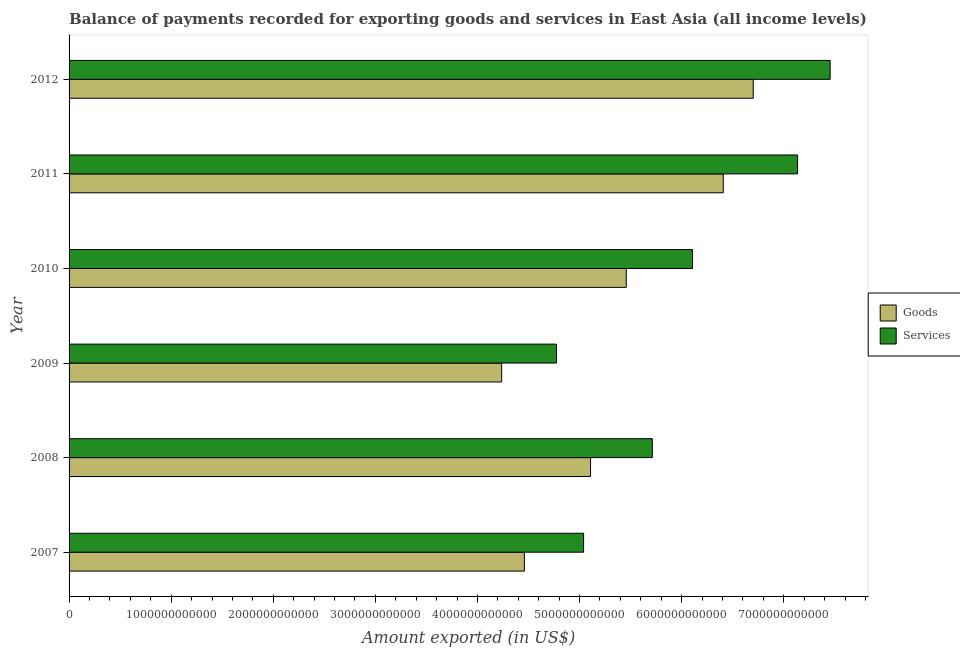Are the number of bars per tick equal to the number of legend labels?
Provide a succinct answer. Yes. How many bars are there on the 1st tick from the top?
Make the answer very short. 2. What is the label of the 2nd group of bars from the top?
Your response must be concise. 2011. In how many cases, is the number of bars for a given year not equal to the number of legend labels?
Your answer should be compact. 0. What is the amount of goods exported in 2007?
Keep it short and to the point. 4.46e+12. Across all years, what is the maximum amount of services exported?
Keep it short and to the point. 7.45e+12. Across all years, what is the minimum amount of goods exported?
Provide a succinct answer. 4.24e+12. In which year was the amount of services exported maximum?
Offer a terse response. 2012. In which year was the amount of goods exported minimum?
Keep it short and to the point. 2009. What is the total amount of services exported in the graph?
Give a very brief answer. 3.62e+13. What is the difference between the amount of services exported in 2007 and that in 2009?
Make the answer very short. 2.66e+11. What is the difference between the amount of services exported in 2008 and the amount of goods exported in 2012?
Ensure brevity in your answer.  -9.88e+11. What is the average amount of services exported per year?
Give a very brief answer. 6.04e+12. In the year 2009, what is the difference between the amount of goods exported and amount of services exported?
Offer a terse response. -5.37e+11. Is the amount of goods exported in 2007 less than that in 2011?
Offer a very short reply. Yes. Is the difference between the amount of services exported in 2008 and 2010 greater than the difference between the amount of goods exported in 2008 and 2010?
Your response must be concise. No. What is the difference between the highest and the second highest amount of services exported?
Offer a terse response. 3.19e+11. What is the difference between the highest and the lowest amount of services exported?
Provide a short and direct response. 2.68e+12. In how many years, is the amount of goods exported greater than the average amount of goods exported taken over all years?
Give a very brief answer. 3. What does the 1st bar from the top in 2012 represents?
Offer a very short reply. Services. What does the 1st bar from the bottom in 2011 represents?
Offer a terse response. Goods. How many years are there in the graph?
Your answer should be very brief. 6. What is the difference between two consecutive major ticks on the X-axis?
Your response must be concise. 1.00e+12. Are the values on the major ticks of X-axis written in scientific E-notation?
Your response must be concise. No. Does the graph contain any zero values?
Offer a very short reply. No. Where does the legend appear in the graph?
Give a very brief answer. Center right. How many legend labels are there?
Your answer should be very brief. 2. What is the title of the graph?
Offer a terse response. Balance of payments recorded for exporting goods and services in East Asia (all income levels). What is the label or title of the X-axis?
Your answer should be very brief. Amount exported (in US$). What is the Amount exported (in US$) of Goods in 2007?
Keep it short and to the point. 4.46e+12. What is the Amount exported (in US$) of Services in 2007?
Make the answer very short. 5.04e+12. What is the Amount exported (in US$) of Goods in 2008?
Your response must be concise. 5.11e+12. What is the Amount exported (in US$) in Services in 2008?
Provide a succinct answer. 5.71e+12. What is the Amount exported (in US$) of Goods in 2009?
Your response must be concise. 4.24e+12. What is the Amount exported (in US$) of Services in 2009?
Offer a terse response. 4.77e+12. What is the Amount exported (in US$) of Goods in 2010?
Keep it short and to the point. 5.46e+12. What is the Amount exported (in US$) in Services in 2010?
Keep it short and to the point. 6.11e+12. What is the Amount exported (in US$) in Goods in 2011?
Your answer should be compact. 6.41e+12. What is the Amount exported (in US$) in Services in 2011?
Give a very brief answer. 7.14e+12. What is the Amount exported (in US$) of Goods in 2012?
Your answer should be compact. 6.70e+12. What is the Amount exported (in US$) in Services in 2012?
Offer a very short reply. 7.45e+12. Across all years, what is the maximum Amount exported (in US$) of Goods?
Make the answer very short. 6.70e+12. Across all years, what is the maximum Amount exported (in US$) of Services?
Your answer should be compact. 7.45e+12. Across all years, what is the minimum Amount exported (in US$) in Goods?
Provide a succinct answer. 4.24e+12. Across all years, what is the minimum Amount exported (in US$) in Services?
Your answer should be very brief. 4.77e+12. What is the total Amount exported (in US$) of Goods in the graph?
Offer a very short reply. 3.24e+13. What is the total Amount exported (in US$) of Services in the graph?
Give a very brief answer. 3.62e+13. What is the difference between the Amount exported (in US$) in Goods in 2007 and that in 2008?
Your answer should be very brief. -6.48e+11. What is the difference between the Amount exported (in US$) of Services in 2007 and that in 2008?
Offer a very short reply. -6.73e+11. What is the difference between the Amount exported (in US$) in Goods in 2007 and that in 2009?
Your answer should be compact. 2.22e+11. What is the difference between the Amount exported (in US$) of Services in 2007 and that in 2009?
Offer a terse response. 2.66e+11. What is the difference between the Amount exported (in US$) of Goods in 2007 and that in 2010?
Provide a succinct answer. -9.98e+11. What is the difference between the Amount exported (in US$) of Services in 2007 and that in 2010?
Provide a short and direct response. -1.07e+12. What is the difference between the Amount exported (in US$) of Goods in 2007 and that in 2011?
Offer a very short reply. -1.95e+12. What is the difference between the Amount exported (in US$) in Services in 2007 and that in 2011?
Keep it short and to the point. -2.10e+12. What is the difference between the Amount exported (in US$) of Goods in 2007 and that in 2012?
Keep it short and to the point. -2.24e+12. What is the difference between the Amount exported (in US$) of Services in 2007 and that in 2012?
Keep it short and to the point. -2.41e+12. What is the difference between the Amount exported (in US$) in Goods in 2008 and that in 2009?
Your response must be concise. 8.71e+11. What is the difference between the Amount exported (in US$) of Services in 2008 and that in 2009?
Your response must be concise. 9.39e+11. What is the difference between the Amount exported (in US$) in Goods in 2008 and that in 2010?
Offer a terse response. -3.50e+11. What is the difference between the Amount exported (in US$) of Services in 2008 and that in 2010?
Keep it short and to the point. -3.94e+11. What is the difference between the Amount exported (in US$) in Goods in 2008 and that in 2011?
Your response must be concise. -1.30e+12. What is the difference between the Amount exported (in US$) in Services in 2008 and that in 2011?
Provide a succinct answer. -1.42e+12. What is the difference between the Amount exported (in US$) in Goods in 2008 and that in 2012?
Offer a very short reply. -1.59e+12. What is the difference between the Amount exported (in US$) of Services in 2008 and that in 2012?
Your answer should be very brief. -1.74e+12. What is the difference between the Amount exported (in US$) in Goods in 2009 and that in 2010?
Provide a succinct answer. -1.22e+12. What is the difference between the Amount exported (in US$) in Services in 2009 and that in 2010?
Make the answer very short. -1.33e+12. What is the difference between the Amount exported (in US$) of Goods in 2009 and that in 2011?
Your answer should be very brief. -2.17e+12. What is the difference between the Amount exported (in US$) of Services in 2009 and that in 2011?
Keep it short and to the point. -2.36e+12. What is the difference between the Amount exported (in US$) of Goods in 2009 and that in 2012?
Provide a succinct answer. -2.46e+12. What is the difference between the Amount exported (in US$) of Services in 2009 and that in 2012?
Provide a succinct answer. -2.68e+12. What is the difference between the Amount exported (in US$) of Goods in 2010 and that in 2011?
Keep it short and to the point. -9.50e+11. What is the difference between the Amount exported (in US$) in Services in 2010 and that in 2011?
Give a very brief answer. -1.03e+12. What is the difference between the Amount exported (in US$) in Goods in 2010 and that in 2012?
Offer a terse response. -1.24e+12. What is the difference between the Amount exported (in US$) of Services in 2010 and that in 2012?
Keep it short and to the point. -1.35e+12. What is the difference between the Amount exported (in US$) of Goods in 2011 and that in 2012?
Offer a terse response. -2.93e+11. What is the difference between the Amount exported (in US$) of Services in 2011 and that in 2012?
Provide a succinct answer. -3.19e+11. What is the difference between the Amount exported (in US$) in Goods in 2007 and the Amount exported (in US$) in Services in 2008?
Your answer should be compact. -1.25e+12. What is the difference between the Amount exported (in US$) in Goods in 2007 and the Amount exported (in US$) in Services in 2009?
Your answer should be very brief. -3.14e+11. What is the difference between the Amount exported (in US$) in Goods in 2007 and the Amount exported (in US$) in Services in 2010?
Provide a succinct answer. -1.65e+12. What is the difference between the Amount exported (in US$) of Goods in 2007 and the Amount exported (in US$) of Services in 2011?
Provide a succinct answer. -2.68e+12. What is the difference between the Amount exported (in US$) of Goods in 2007 and the Amount exported (in US$) of Services in 2012?
Your answer should be compact. -2.99e+12. What is the difference between the Amount exported (in US$) in Goods in 2008 and the Amount exported (in US$) in Services in 2009?
Your answer should be very brief. 3.34e+11. What is the difference between the Amount exported (in US$) of Goods in 2008 and the Amount exported (in US$) of Services in 2010?
Your response must be concise. -9.99e+11. What is the difference between the Amount exported (in US$) of Goods in 2008 and the Amount exported (in US$) of Services in 2011?
Make the answer very short. -2.03e+12. What is the difference between the Amount exported (in US$) in Goods in 2008 and the Amount exported (in US$) in Services in 2012?
Provide a succinct answer. -2.35e+12. What is the difference between the Amount exported (in US$) of Goods in 2009 and the Amount exported (in US$) of Services in 2010?
Your response must be concise. -1.87e+12. What is the difference between the Amount exported (in US$) in Goods in 2009 and the Amount exported (in US$) in Services in 2011?
Your answer should be very brief. -2.90e+12. What is the difference between the Amount exported (in US$) in Goods in 2009 and the Amount exported (in US$) in Services in 2012?
Ensure brevity in your answer.  -3.22e+12. What is the difference between the Amount exported (in US$) of Goods in 2010 and the Amount exported (in US$) of Services in 2011?
Your answer should be very brief. -1.68e+12. What is the difference between the Amount exported (in US$) in Goods in 2010 and the Amount exported (in US$) in Services in 2012?
Your response must be concise. -2.00e+12. What is the difference between the Amount exported (in US$) of Goods in 2011 and the Amount exported (in US$) of Services in 2012?
Give a very brief answer. -1.05e+12. What is the average Amount exported (in US$) of Goods per year?
Offer a very short reply. 5.40e+12. What is the average Amount exported (in US$) in Services per year?
Make the answer very short. 6.04e+12. In the year 2007, what is the difference between the Amount exported (in US$) in Goods and Amount exported (in US$) in Services?
Your response must be concise. -5.80e+11. In the year 2008, what is the difference between the Amount exported (in US$) in Goods and Amount exported (in US$) in Services?
Ensure brevity in your answer.  -6.05e+11. In the year 2009, what is the difference between the Amount exported (in US$) of Goods and Amount exported (in US$) of Services?
Your response must be concise. -5.37e+11. In the year 2010, what is the difference between the Amount exported (in US$) of Goods and Amount exported (in US$) of Services?
Offer a very short reply. -6.49e+11. In the year 2011, what is the difference between the Amount exported (in US$) in Goods and Amount exported (in US$) in Services?
Ensure brevity in your answer.  -7.28e+11. In the year 2012, what is the difference between the Amount exported (in US$) in Goods and Amount exported (in US$) in Services?
Your answer should be compact. -7.53e+11. What is the ratio of the Amount exported (in US$) of Goods in 2007 to that in 2008?
Offer a very short reply. 0.87. What is the ratio of the Amount exported (in US$) in Services in 2007 to that in 2008?
Provide a short and direct response. 0.88. What is the ratio of the Amount exported (in US$) of Goods in 2007 to that in 2009?
Make the answer very short. 1.05. What is the ratio of the Amount exported (in US$) in Services in 2007 to that in 2009?
Provide a succinct answer. 1.06. What is the ratio of the Amount exported (in US$) of Goods in 2007 to that in 2010?
Ensure brevity in your answer.  0.82. What is the ratio of the Amount exported (in US$) in Services in 2007 to that in 2010?
Your answer should be compact. 0.83. What is the ratio of the Amount exported (in US$) in Goods in 2007 to that in 2011?
Ensure brevity in your answer.  0.7. What is the ratio of the Amount exported (in US$) of Services in 2007 to that in 2011?
Make the answer very short. 0.71. What is the ratio of the Amount exported (in US$) of Goods in 2007 to that in 2012?
Your answer should be compact. 0.67. What is the ratio of the Amount exported (in US$) in Services in 2007 to that in 2012?
Provide a succinct answer. 0.68. What is the ratio of the Amount exported (in US$) in Goods in 2008 to that in 2009?
Your response must be concise. 1.21. What is the ratio of the Amount exported (in US$) in Services in 2008 to that in 2009?
Provide a succinct answer. 1.2. What is the ratio of the Amount exported (in US$) in Goods in 2008 to that in 2010?
Give a very brief answer. 0.94. What is the ratio of the Amount exported (in US$) of Services in 2008 to that in 2010?
Offer a very short reply. 0.94. What is the ratio of the Amount exported (in US$) in Goods in 2008 to that in 2011?
Offer a very short reply. 0.8. What is the ratio of the Amount exported (in US$) in Services in 2008 to that in 2011?
Provide a short and direct response. 0.8. What is the ratio of the Amount exported (in US$) of Goods in 2008 to that in 2012?
Make the answer very short. 0.76. What is the ratio of the Amount exported (in US$) in Services in 2008 to that in 2012?
Ensure brevity in your answer.  0.77. What is the ratio of the Amount exported (in US$) in Goods in 2009 to that in 2010?
Ensure brevity in your answer.  0.78. What is the ratio of the Amount exported (in US$) in Services in 2009 to that in 2010?
Make the answer very short. 0.78. What is the ratio of the Amount exported (in US$) of Goods in 2009 to that in 2011?
Give a very brief answer. 0.66. What is the ratio of the Amount exported (in US$) in Services in 2009 to that in 2011?
Ensure brevity in your answer.  0.67. What is the ratio of the Amount exported (in US$) in Goods in 2009 to that in 2012?
Keep it short and to the point. 0.63. What is the ratio of the Amount exported (in US$) of Services in 2009 to that in 2012?
Make the answer very short. 0.64. What is the ratio of the Amount exported (in US$) of Goods in 2010 to that in 2011?
Keep it short and to the point. 0.85. What is the ratio of the Amount exported (in US$) of Services in 2010 to that in 2011?
Your answer should be compact. 0.86. What is the ratio of the Amount exported (in US$) in Goods in 2010 to that in 2012?
Provide a succinct answer. 0.81. What is the ratio of the Amount exported (in US$) of Services in 2010 to that in 2012?
Offer a very short reply. 0.82. What is the ratio of the Amount exported (in US$) of Goods in 2011 to that in 2012?
Provide a succinct answer. 0.96. What is the ratio of the Amount exported (in US$) of Services in 2011 to that in 2012?
Ensure brevity in your answer.  0.96. What is the difference between the highest and the second highest Amount exported (in US$) in Goods?
Offer a terse response. 2.93e+11. What is the difference between the highest and the second highest Amount exported (in US$) of Services?
Give a very brief answer. 3.19e+11. What is the difference between the highest and the lowest Amount exported (in US$) in Goods?
Offer a terse response. 2.46e+12. What is the difference between the highest and the lowest Amount exported (in US$) of Services?
Keep it short and to the point. 2.68e+12. 